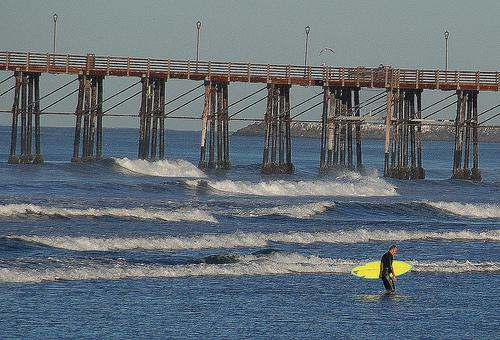Question: what is the color of the water?
Choices:
A. Green.
B. Clear.
C. White.
D. Blue.
Answer with the letter. Answer: D Question: what is the color of the wakeboard?
Choices:
A. Yellow.
B. White.
C. Blue.
D. Pink.
Answer with the letter. Answer: A Question: how is the beach?
Choices:
A. Nice.
B. Calm.
C. Ruff.
D. With waves.
Answer with the letter. Answer: D 